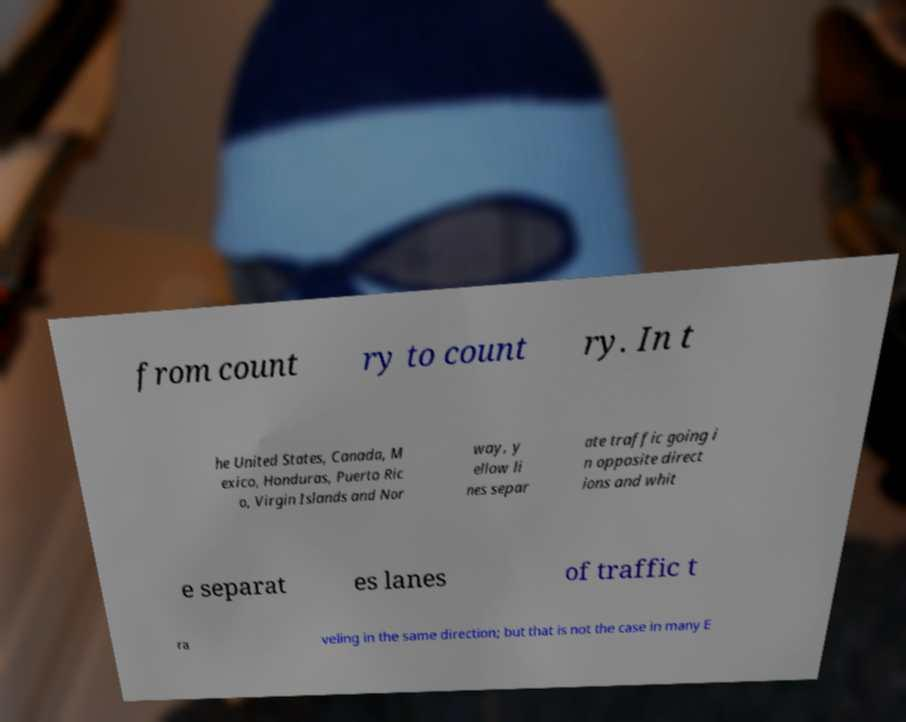For documentation purposes, I need the text within this image transcribed. Could you provide that? from count ry to count ry. In t he United States, Canada, M exico, Honduras, Puerto Ric o, Virgin Islands and Nor way, y ellow li nes separ ate traffic going i n opposite direct ions and whit e separat es lanes of traffic t ra veling in the same direction; but that is not the case in many E 